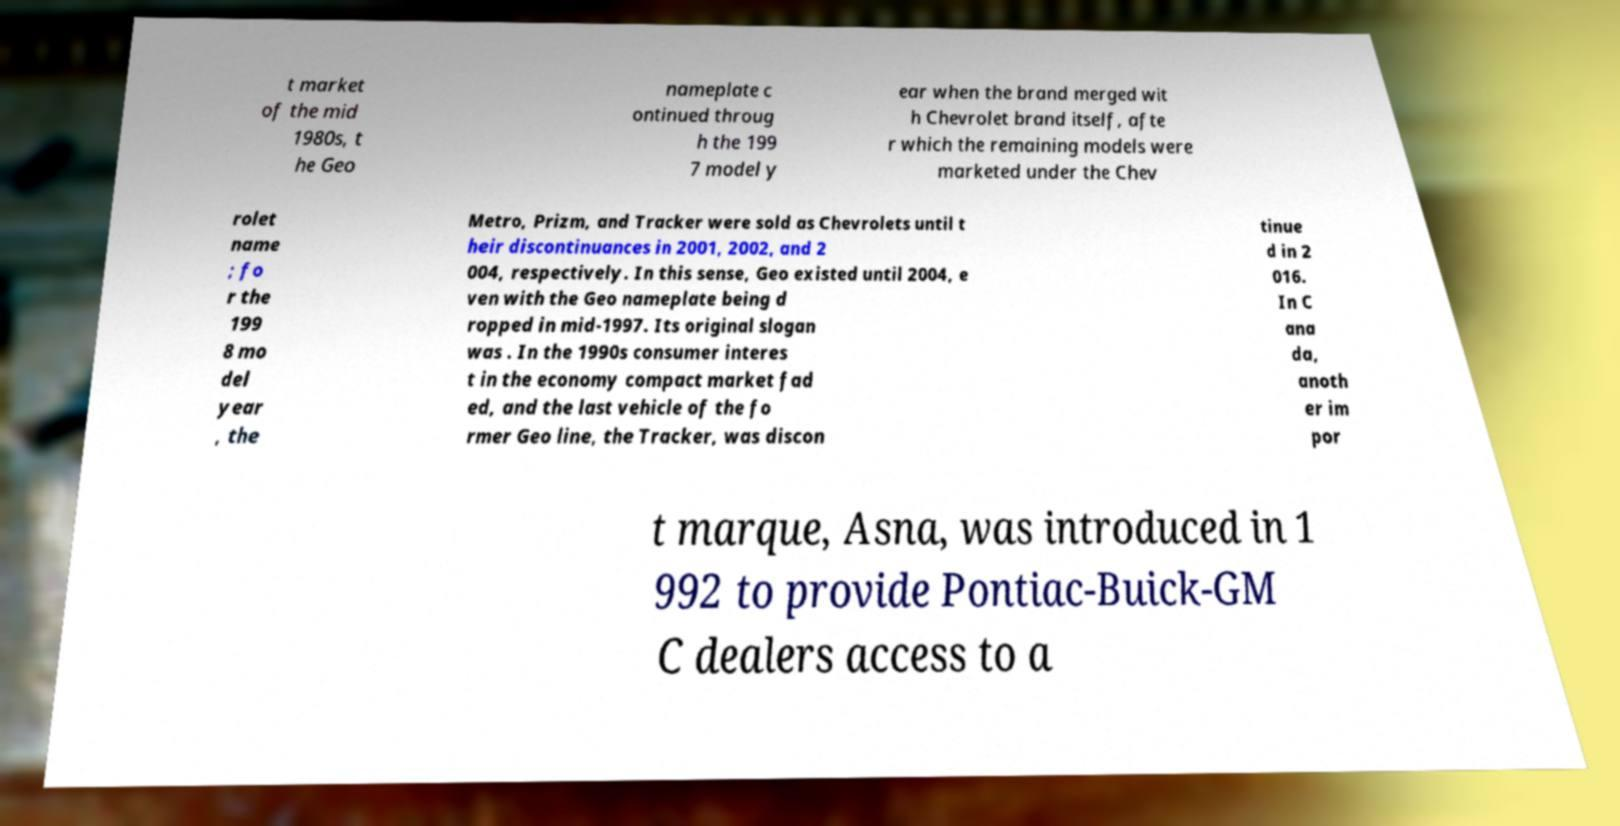For documentation purposes, I need the text within this image transcribed. Could you provide that? t market of the mid 1980s, t he Geo nameplate c ontinued throug h the 199 7 model y ear when the brand merged wit h Chevrolet brand itself, afte r which the remaining models were marketed under the Chev rolet name ; fo r the 199 8 mo del year , the Metro, Prizm, and Tracker were sold as Chevrolets until t heir discontinuances in 2001, 2002, and 2 004, respectively. In this sense, Geo existed until 2004, e ven with the Geo nameplate being d ropped in mid-1997. Its original slogan was . In the 1990s consumer interes t in the economy compact market fad ed, and the last vehicle of the fo rmer Geo line, the Tracker, was discon tinue d in 2 016. In C ana da, anoth er im por t marque, Asna, was introduced in 1 992 to provide Pontiac-Buick-GM C dealers access to a 